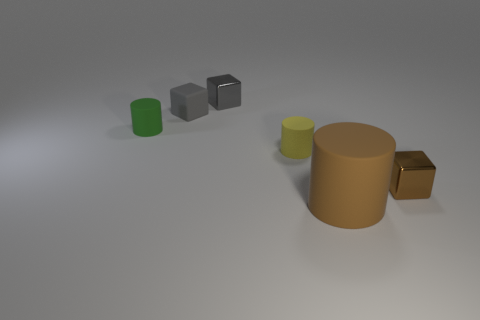Add 3 tiny green cylinders. How many objects exist? 9 Add 5 rubber things. How many rubber things exist? 9 Subtract 0 cyan blocks. How many objects are left? 6 Subtract all tiny rubber objects. Subtract all brown cylinders. How many objects are left? 2 Add 5 tiny rubber cylinders. How many tiny rubber cylinders are left? 7 